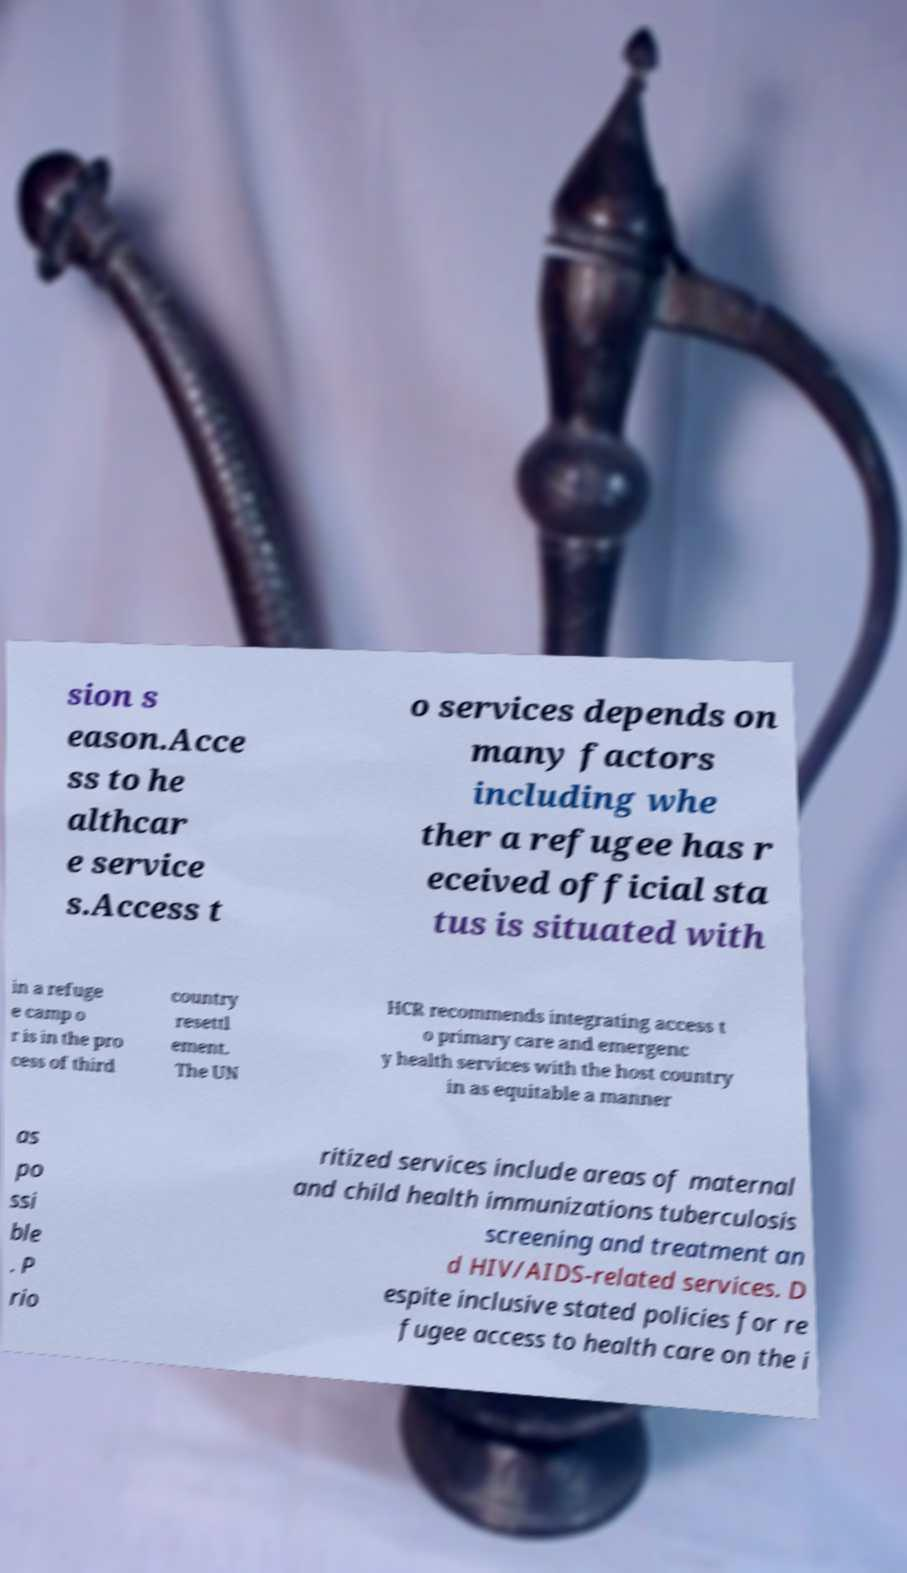There's text embedded in this image that I need extracted. Can you transcribe it verbatim? sion s eason.Acce ss to he althcar e service s.Access t o services depends on many factors including whe ther a refugee has r eceived official sta tus is situated with in a refuge e camp o r is in the pro cess of third country resettl ement. The UN HCR recommends integrating access t o primary care and emergenc y health services with the host country in as equitable a manner as po ssi ble . P rio ritized services include areas of maternal and child health immunizations tuberculosis screening and treatment an d HIV/AIDS-related services. D espite inclusive stated policies for re fugee access to health care on the i 